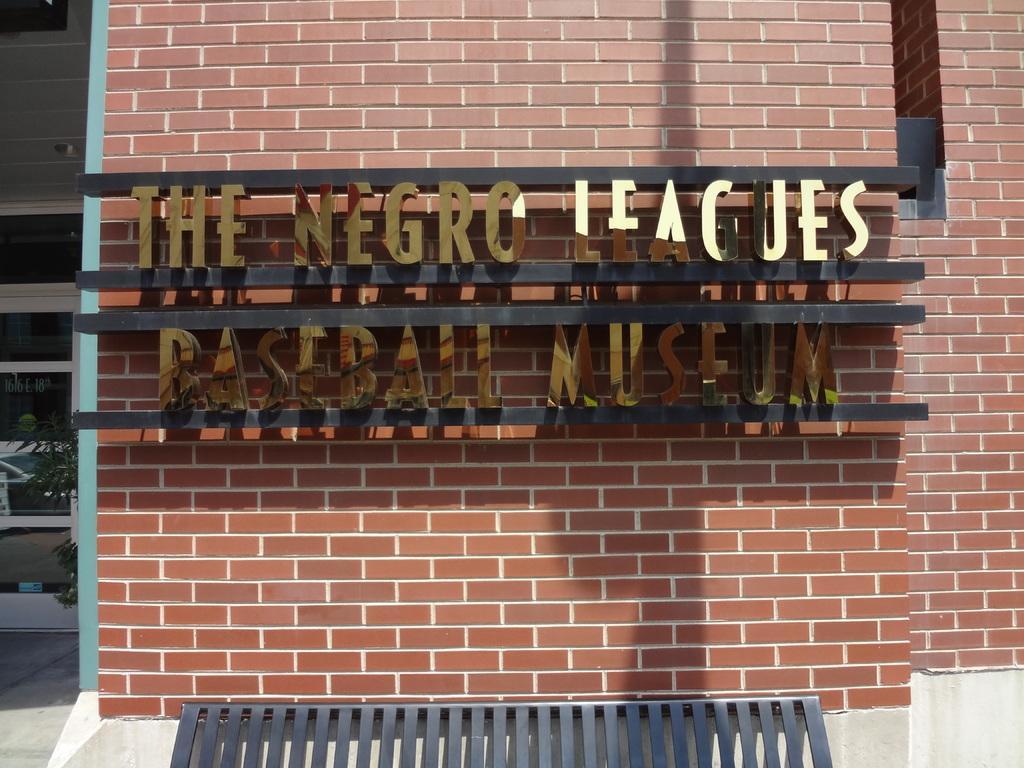Describe this image in one or two sentences. In this image there is a wall, there is text on the wall, there is a plant, there is a window towards the left of the image, there is an object towards the left of the image, there is an object towards the bottom of the image. 